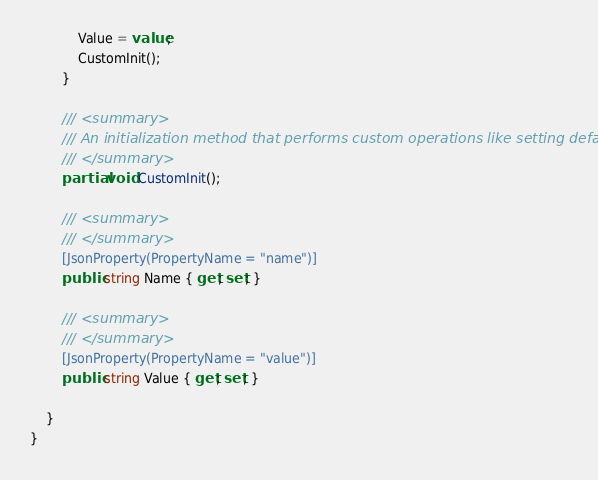<code> <loc_0><loc_0><loc_500><loc_500><_C#_>            Value = value;
            CustomInit();
        }

        /// <summary>
        /// An initialization method that performs custom operations like setting defaults
        /// </summary>
        partial void CustomInit();

        /// <summary>
        /// </summary>
        [JsonProperty(PropertyName = "name")]
        public string Name { get; set; }

        /// <summary>
        /// </summary>
        [JsonProperty(PropertyName = "value")]
        public string Value { get; set; }

    }
}
</code> 